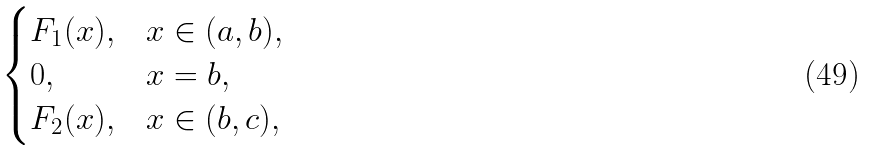<formula> <loc_0><loc_0><loc_500><loc_500>\begin{cases} F _ { 1 } ( x ) , & x \in ( a , b ) , \\ 0 , & x = b , \\ F _ { 2 } ( x ) , & x \in ( b , c ) , \end{cases}</formula> 